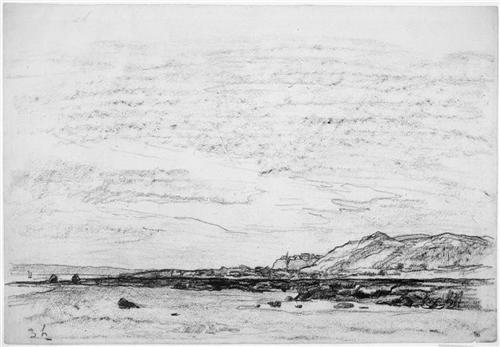What could be the possible inspiration behind this landscape sketch? This landscape sketch could have been inspired by actual geographical locations familiar to the artist or could be an imaginative amalgamation of various landscapes. Artists often draw inspiration from their surroundings, travels, or emotional states. This particular sketch could reflect a place of personal significance to the artist, or it might be an artistic exploration of natural forms and elements like mountains and open skies. 